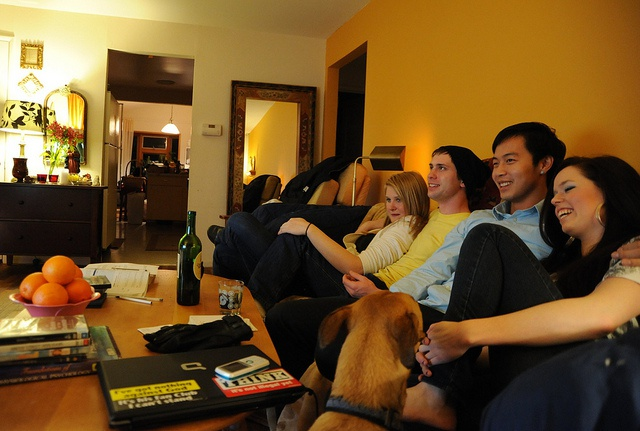Describe the objects in this image and their specific colors. I can see people in lightyellow, black, brown, tan, and maroon tones, dining table in lightyellow, black, brown, maroon, and olive tones, people in lightyellow, black, brown, and olive tones, dog in lightyellow, brown, maroon, and black tones, and laptop in lightyellow, black, tan, and olive tones in this image. 